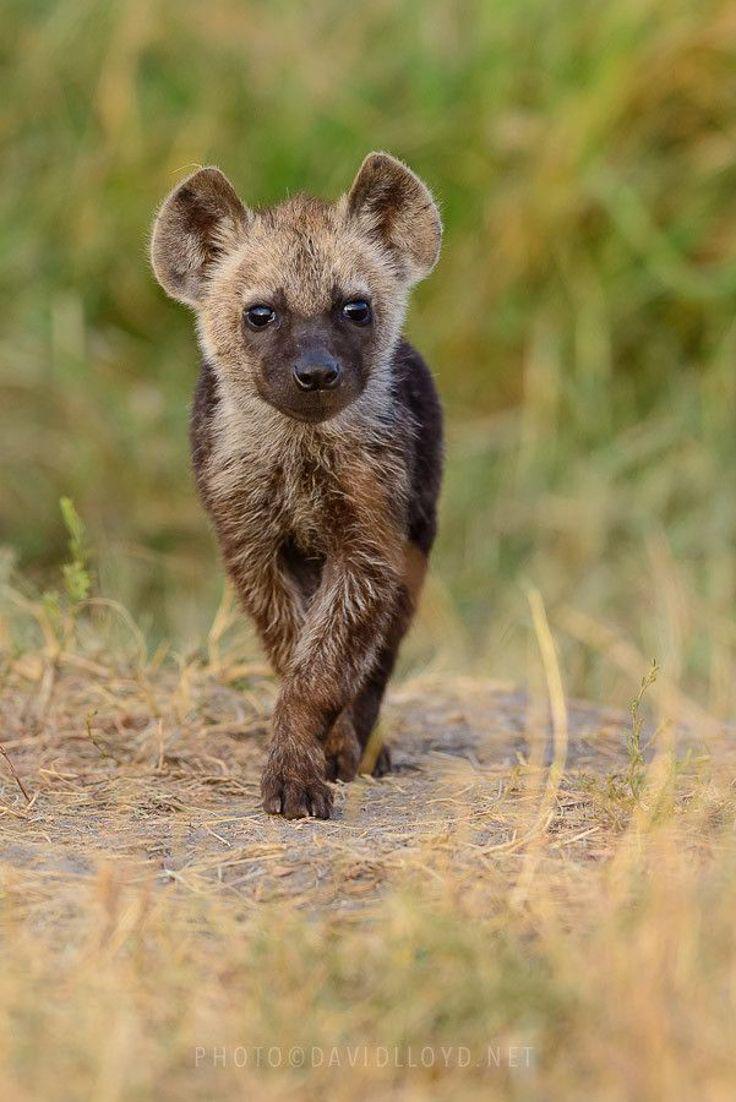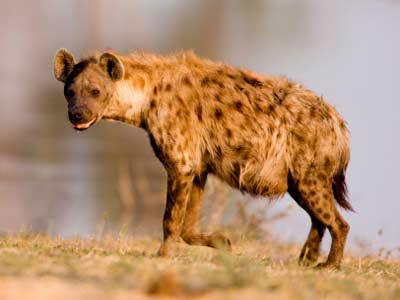The first image is the image on the left, the second image is the image on the right. Considering the images on both sides, is "No hyena is facing left." valid? Answer yes or no. No. 